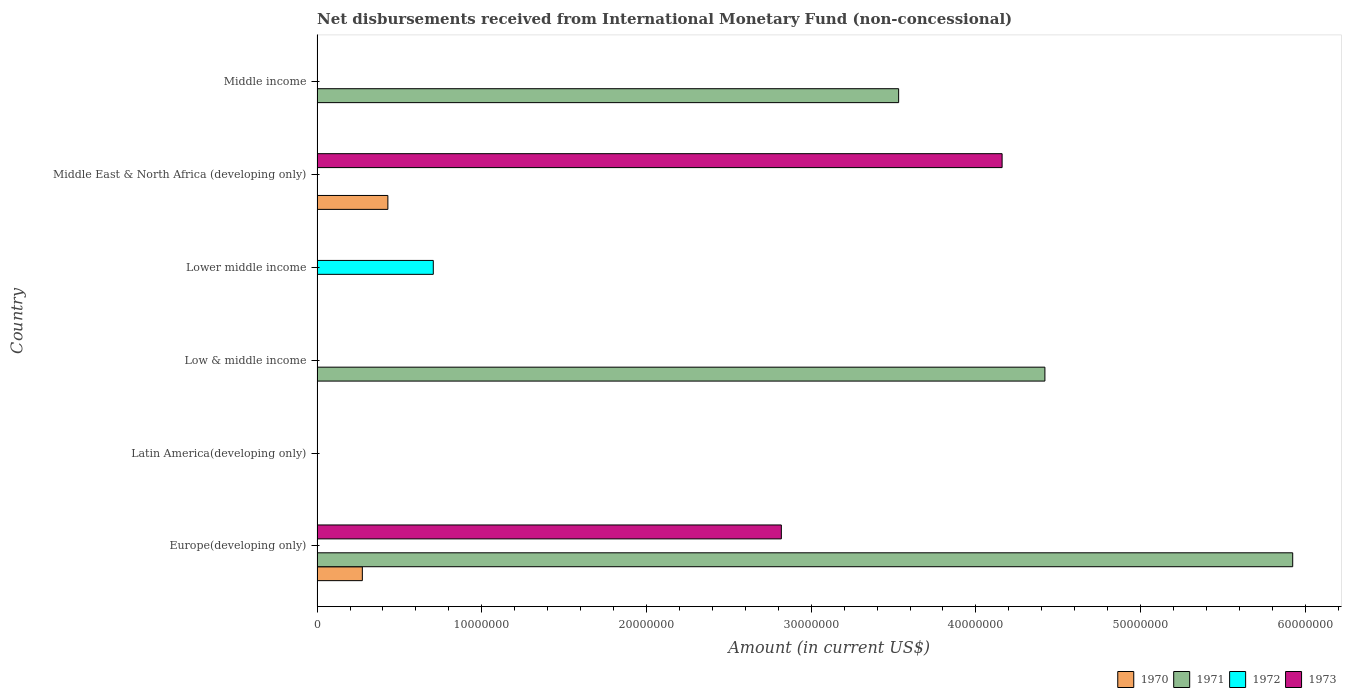Are the number of bars per tick equal to the number of legend labels?
Offer a terse response. No. Are the number of bars on each tick of the Y-axis equal?
Provide a short and direct response. No. How many bars are there on the 2nd tick from the top?
Keep it short and to the point. 2. What is the label of the 6th group of bars from the top?
Ensure brevity in your answer.  Europe(developing only). In how many cases, is the number of bars for a given country not equal to the number of legend labels?
Ensure brevity in your answer.  6. What is the amount of disbursements received from International Monetary Fund in 1973 in Middle income?
Your answer should be compact. 0. Across all countries, what is the maximum amount of disbursements received from International Monetary Fund in 1973?
Keep it short and to the point. 4.16e+07. In which country was the amount of disbursements received from International Monetary Fund in 1973 maximum?
Your answer should be very brief. Middle East & North Africa (developing only). What is the total amount of disbursements received from International Monetary Fund in 1973 in the graph?
Your answer should be compact. 6.98e+07. What is the difference between the amount of disbursements received from International Monetary Fund in 1971 in Low & middle income and that in Middle income?
Make the answer very short. 8.88e+06. What is the difference between the amount of disbursements received from International Monetary Fund in 1972 in Middle income and the amount of disbursements received from International Monetary Fund in 1971 in Low & middle income?
Your response must be concise. -4.42e+07. What is the average amount of disbursements received from International Monetary Fund in 1972 per country?
Your response must be concise. 1.18e+06. What is the difference between the amount of disbursements received from International Monetary Fund in 1970 and amount of disbursements received from International Monetary Fund in 1973 in Europe(developing only)?
Your answer should be very brief. -2.54e+07. In how many countries, is the amount of disbursements received from International Monetary Fund in 1972 greater than 60000000 US$?
Offer a very short reply. 0. What is the difference between the highest and the second highest amount of disbursements received from International Monetary Fund in 1971?
Ensure brevity in your answer.  1.50e+07. What is the difference between the highest and the lowest amount of disbursements received from International Monetary Fund in 1970?
Provide a short and direct response. 4.30e+06. Is it the case that in every country, the sum of the amount of disbursements received from International Monetary Fund in 1971 and amount of disbursements received from International Monetary Fund in 1972 is greater than the amount of disbursements received from International Monetary Fund in 1970?
Your answer should be very brief. No. How many bars are there?
Offer a terse response. 8. How many countries are there in the graph?
Provide a short and direct response. 6. What is the difference between two consecutive major ticks on the X-axis?
Ensure brevity in your answer.  1.00e+07. Are the values on the major ticks of X-axis written in scientific E-notation?
Offer a very short reply. No. Where does the legend appear in the graph?
Make the answer very short. Bottom right. How are the legend labels stacked?
Ensure brevity in your answer.  Horizontal. What is the title of the graph?
Give a very brief answer. Net disbursements received from International Monetary Fund (non-concessional). What is the label or title of the X-axis?
Provide a short and direct response. Amount (in current US$). What is the label or title of the Y-axis?
Provide a short and direct response. Country. What is the Amount (in current US$) of 1970 in Europe(developing only)?
Give a very brief answer. 2.75e+06. What is the Amount (in current US$) of 1971 in Europe(developing only)?
Offer a very short reply. 5.92e+07. What is the Amount (in current US$) in 1972 in Europe(developing only)?
Your response must be concise. 0. What is the Amount (in current US$) in 1973 in Europe(developing only)?
Keep it short and to the point. 2.82e+07. What is the Amount (in current US$) of 1971 in Latin America(developing only)?
Your answer should be compact. 0. What is the Amount (in current US$) of 1972 in Latin America(developing only)?
Offer a very short reply. 0. What is the Amount (in current US$) in 1970 in Low & middle income?
Ensure brevity in your answer.  0. What is the Amount (in current US$) of 1971 in Low & middle income?
Give a very brief answer. 4.42e+07. What is the Amount (in current US$) of 1972 in Low & middle income?
Your answer should be very brief. 0. What is the Amount (in current US$) of 1973 in Low & middle income?
Offer a terse response. 0. What is the Amount (in current US$) of 1971 in Lower middle income?
Your answer should be very brief. 0. What is the Amount (in current US$) of 1972 in Lower middle income?
Keep it short and to the point. 7.06e+06. What is the Amount (in current US$) in 1970 in Middle East & North Africa (developing only)?
Ensure brevity in your answer.  4.30e+06. What is the Amount (in current US$) of 1973 in Middle East & North Africa (developing only)?
Your answer should be very brief. 4.16e+07. What is the Amount (in current US$) in 1971 in Middle income?
Keep it short and to the point. 3.53e+07. What is the Amount (in current US$) in 1972 in Middle income?
Make the answer very short. 0. What is the Amount (in current US$) of 1973 in Middle income?
Offer a terse response. 0. Across all countries, what is the maximum Amount (in current US$) of 1970?
Provide a short and direct response. 4.30e+06. Across all countries, what is the maximum Amount (in current US$) in 1971?
Your response must be concise. 5.92e+07. Across all countries, what is the maximum Amount (in current US$) of 1972?
Make the answer very short. 7.06e+06. Across all countries, what is the maximum Amount (in current US$) of 1973?
Ensure brevity in your answer.  4.16e+07. Across all countries, what is the minimum Amount (in current US$) of 1972?
Your response must be concise. 0. What is the total Amount (in current US$) of 1970 in the graph?
Your answer should be compact. 7.05e+06. What is the total Amount (in current US$) in 1971 in the graph?
Ensure brevity in your answer.  1.39e+08. What is the total Amount (in current US$) of 1972 in the graph?
Provide a succinct answer. 7.06e+06. What is the total Amount (in current US$) in 1973 in the graph?
Keep it short and to the point. 6.98e+07. What is the difference between the Amount (in current US$) in 1971 in Europe(developing only) and that in Low & middle income?
Make the answer very short. 1.50e+07. What is the difference between the Amount (in current US$) of 1970 in Europe(developing only) and that in Middle East & North Africa (developing only)?
Keep it short and to the point. -1.55e+06. What is the difference between the Amount (in current US$) in 1973 in Europe(developing only) and that in Middle East & North Africa (developing only)?
Provide a succinct answer. -1.34e+07. What is the difference between the Amount (in current US$) in 1971 in Europe(developing only) and that in Middle income?
Your answer should be very brief. 2.39e+07. What is the difference between the Amount (in current US$) in 1971 in Low & middle income and that in Middle income?
Your answer should be compact. 8.88e+06. What is the difference between the Amount (in current US$) in 1970 in Europe(developing only) and the Amount (in current US$) in 1971 in Low & middle income?
Your answer should be very brief. -4.14e+07. What is the difference between the Amount (in current US$) of 1970 in Europe(developing only) and the Amount (in current US$) of 1972 in Lower middle income?
Your response must be concise. -4.31e+06. What is the difference between the Amount (in current US$) in 1971 in Europe(developing only) and the Amount (in current US$) in 1972 in Lower middle income?
Make the answer very short. 5.22e+07. What is the difference between the Amount (in current US$) in 1970 in Europe(developing only) and the Amount (in current US$) in 1973 in Middle East & North Africa (developing only)?
Give a very brief answer. -3.88e+07. What is the difference between the Amount (in current US$) of 1971 in Europe(developing only) and the Amount (in current US$) of 1973 in Middle East & North Africa (developing only)?
Give a very brief answer. 1.76e+07. What is the difference between the Amount (in current US$) in 1970 in Europe(developing only) and the Amount (in current US$) in 1971 in Middle income?
Provide a short and direct response. -3.26e+07. What is the difference between the Amount (in current US$) of 1971 in Low & middle income and the Amount (in current US$) of 1972 in Lower middle income?
Ensure brevity in your answer.  3.71e+07. What is the difference between the Amount (in current US$) of 1971 in Low & middle income and the Amount (in current US$) of 1973 in Middle East & North Africa (developing only)?
Ensure brevity in your answer.  2.60e+06. What is the difference between the Amount (in current US$) in 1972 in Lower middle income and the Amount (in current US$) in 1973 in Middle East & North Africa (developing only)?
Ensure brevity in your answer.  -3.45e+07. What is the difference between the Amount (in current US$) of 1970 in Middle East & North Africa (developing only) and the Amount (in current US$) of 1971 in Middle income?
Your answer should be compact. -3.10e+07. What is the average Amount (in current US$) of 1970 per country?
Keep it short and to the point. 1.18e+06. What is the average Amount (in current US$) in 1971 per country?
Offer a terse response. 2.31e+07. What is the average Amount (in current US$) of 1972 per country?
Your answer should be very brief. 1.18e+06. What is the average Amount (in current US$) in 1973 per country?
Give a very brief answer. 1.16e+07. What is the difference between the Amount (in current US$) in 1970 and Amount (in current US$) in 1971 in Europe(developing only)?
Make the answer very short. -5.65e+07. What is the difference between the Amount (in current US$) of 1970 and Amount (in current US$) of 1973 in Europe(developing only)?
Your response must be concise. -2.54e+07. What is the difference between the Amount (in current US$) in 1971 and Amount (in current US$) in 1973 in Europe(developing only)?
Offer a terse response. 3.10e+07. What is the difference between the Amount (in current US$) of 1970 and Amount (in current US$) of 1973 in Middle East & North Africa (developing only)?
Provide a succinct answer. -3.73e+07. What is the ratio of the Amount (in current US$) in 1971 in Europe(developing only) to that in Low & middle income?
Give a very brief answer. 1.34. What is the ratio of the Amount (in current US$) in 1970 in Europe(developing only) to that in Middle East & North Africa (developing only)?
Your response must be concise. 0.64. What is the ratio of the Amount (in current US$) of 1973 in Europe(developing only) to that in Middle East & North Africa (developing only)?
Offer a very short reply. 0.68. What is the ratio of the Amount (in current US$) in 1971 in Europe(developing only) to that in Middle income?
Ensure brevity in your answer.  1.68. What is the ratio of the Amount (in current US$) in 1971 in Low & middle income to that in Middle income?
Your answer should be very brief. 1.25. What is the difference between the highest and the second highest Amount (in current US$) in 1971?
Your answer should be compact. 1.50e+07. What is the difference between the highest and the lowest Amount (in current US$) in 1970?
Keep it short and to the point. 4.30e+06. What is the difference between the highest and the lowest Amount (in current US$) of 1971?
Offer a terse response. 5.92e+07. What is the difference between the highest and the lowest Amount (in current US$) of 1972?
Your response must be concise. 7.06e+06. What is the difference between the highest and the lowest Amount (in current US$) in 1973?
Keep it short and to the point. 4.16e+07. 